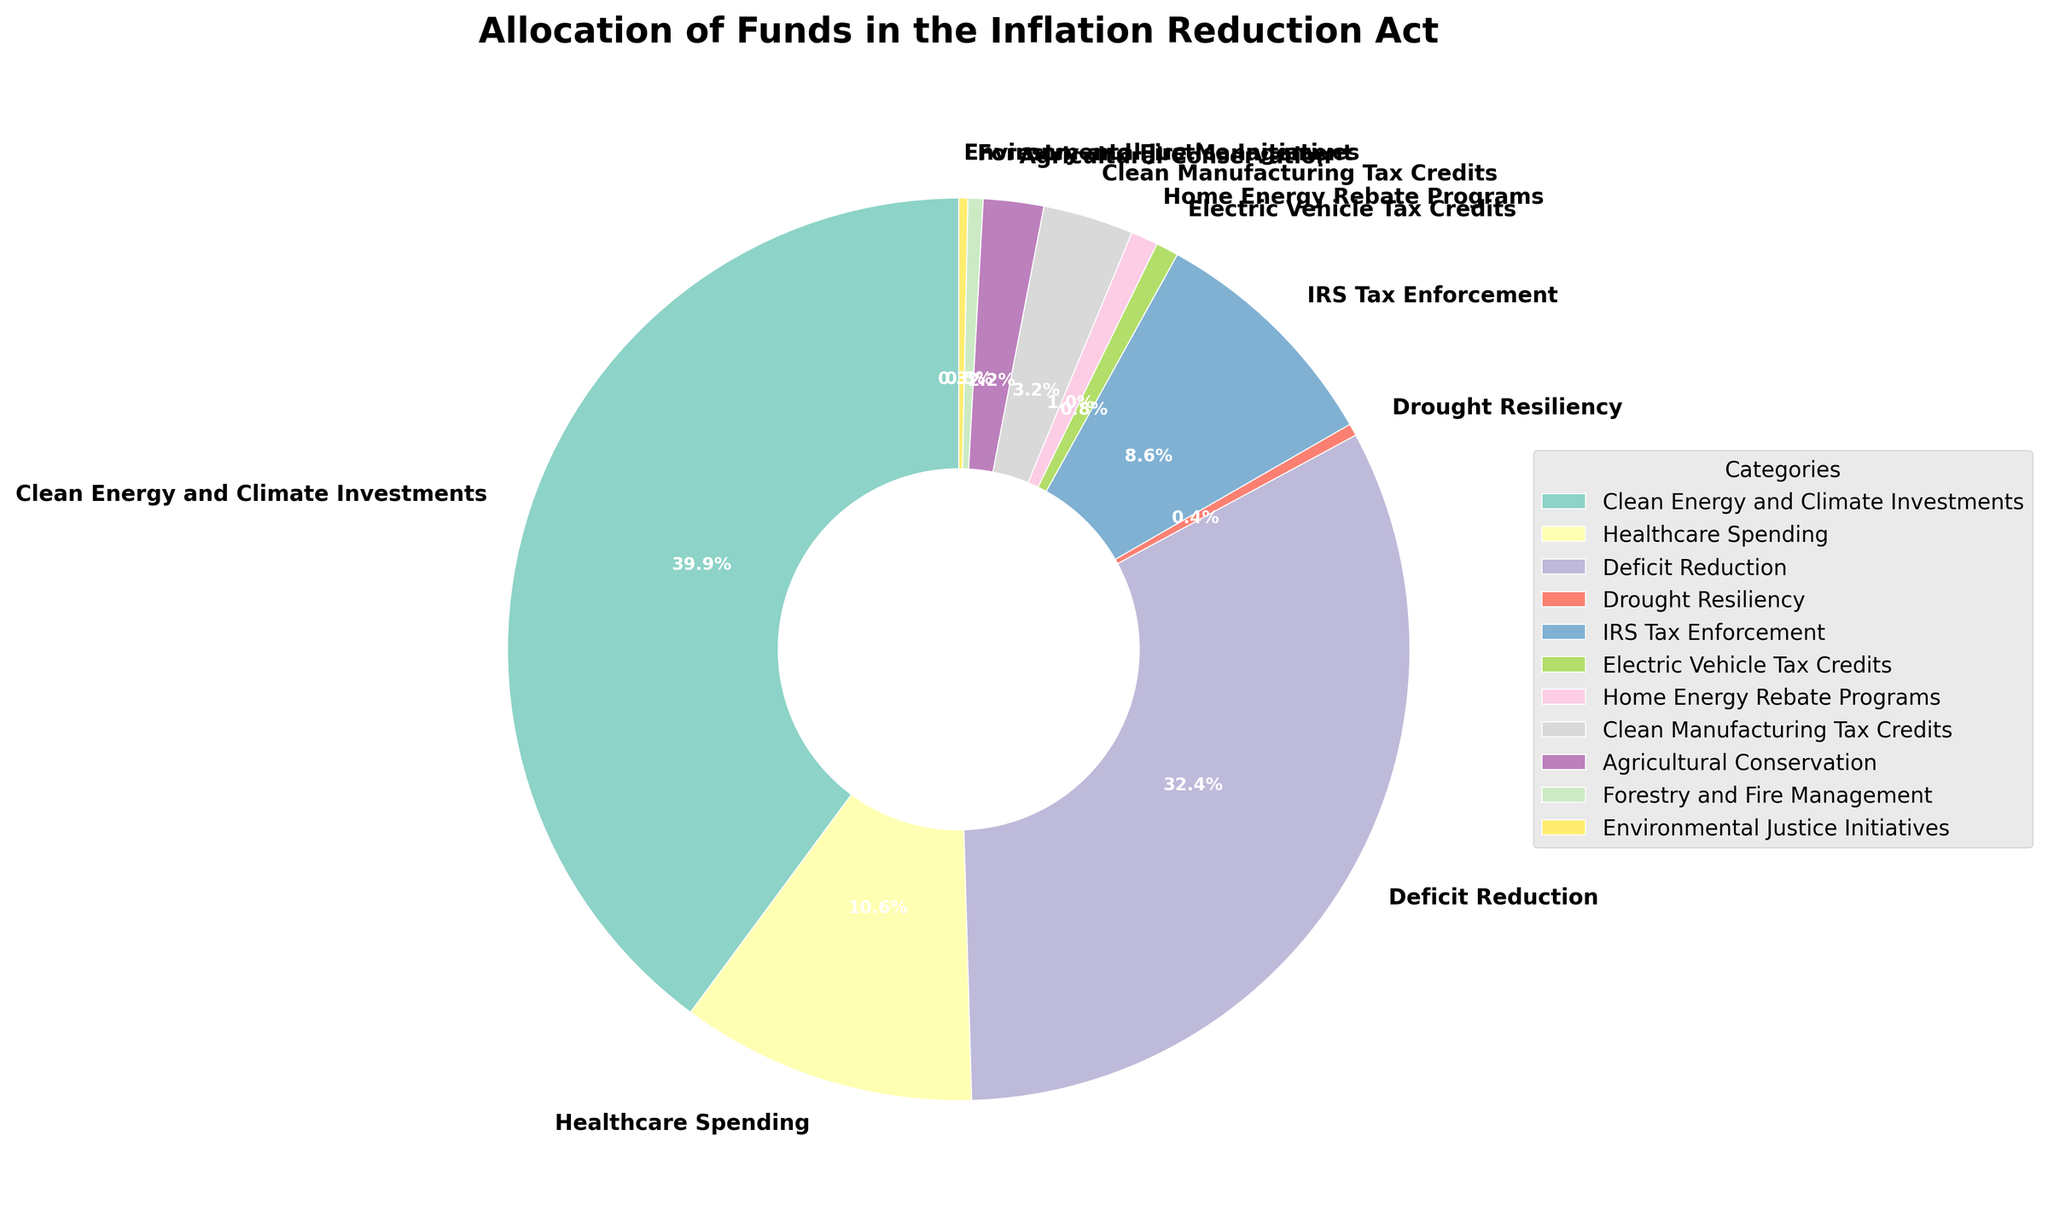Which category receives the largest allocation of funds? The category with the largest portion of the pie chart represents the greatest allocation amount. Looking at the chart, "Clean Energy and Climate Investments" takes the largest share.
Answer: Clean Energy and Climate Investments How much more is allocated to Deficit Reduction compared to Healthcare Spending? Identify the allocation amounts for both categories from the chart (300 billion for Deficit Reduction and 98 billion for Healthcare Spending). Subtract the smaller value from the larger one: 300 - 98 = 202 billion.
Answer: 202 billion What is the total allocation for IRS Tax Enforcement and Electric Vehicle Tax Credits combined? Sum the allocation amounts for both categories: IRS Tax Enforcement (80 billion) and Electric Vehicle Tax Credits (7.5 billion). Adding these, 80 + 7.5 = 87.5 billion.
Answer: 87.5 billion Compare the allocations for Home Energy Rebate Programs and Environmental Justice Initiatives. Which category receives more funding and by how much? Check the allocation amounts: Home Energy Rebate Programs (9 billion) and Environmental Justice Initiatives (3 billion). Subtract the smaller from the larger: 9 - 3 = 6 billion. Home Energy Rebate Programs receive more.
Answer: Home Energy Rebate Programs by 6 billion Which category has a smaller allocation, Agricultural Conservation or Forestry and Fire Management? Refer to the allocation amounts for both: Agricultural Conservation (20 billion) and Forestry and Fire Management (5 billion). The smaller allocation is Forestry and Fire Management.
Answer: Forestry and Fire Management What is the combined percentage of the total allocation represented by Drought Resiliency and Environmental Justice Initiatives? First, add the allocation amounts for these categories: Drought Resiliency (4 billion) + Environmental Justice Initiatives (3 billion) = 7 billion. Then, sum up all allocations to find the total: 920. Divide 7 by 920, then multiply by 100: (7 / 920) * 100 = 0.76%.
Answer: 0.76% Is the allocation for Clean Manufacturing Tax Credits greater than or less than the combined allocation for Drought Resiliency and Environmental Justice Initiatives? Clean Manufacturing Tax Credits has an allocation of 30 billion. Drought Resiliency and Environmental Justice Initiatives combined is 4 + 3 = 7 billion. 30 billion is greater than 7 billion.
Answer: Greater than What category represents approximately one-third of the total funding allocation? Find the category closest to one-third of the total allocation (920 billion). One-third of 920 is roughly 306.67 billion. "Deficit Reduction" is close to this with 300 billion.
Answer: Deficit Reduction What is the percentage difference between the funding for Clean Energy and Climate Investments and IRS Tax Enforcement? Allocation for Clean Energy and Climate Investments is 369 billion and for IRS Tax Enforcement is 80 billion. The difference is 369 - 80 = 289 billion. Divide this by the total allocation: (289 / 920) * 100 = 31.41%.
Answer: 31.41% 